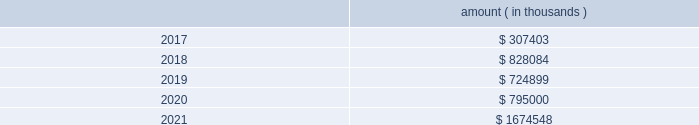Entergy corporation and subsidiaries notes to financial statements ( a ) consists of pollution control revenue bonds and environmental revenue bonds , some of which are secured by collateral first mortgage bonds .
( b ) these notes do not have a stated interest rate , but have an implicit interest rate of 4.8% ( 4.8 % ) .
( c ) pursuant to the nuclear waste policy act of 1982 , entergy 2019s nuclear owner/licensee subsidiaries have contracts with the doe for spent nuclear fuel disposal service .
The contracts include a one-time fee for generation prior to april 7 , 1983 .
Entergy arkansas is the only entergy company that generated electric power with nuclear fuel prior to that date and includes the one-time fee , plus accrued interest , in long-term debt .
( d ) see note 10 to the financial statements for further discussion of the waterford 3 lease obligation and entergy louisiana 2019s acquisition of the equity participant 2019s beneficial interest in the waterford 3 leased assets and for further discussion of the grand gulf lease obligation .
( e ) this note does not have a stated interest rate , but has an implicit interest rate of 7.458% ( 7.458 % ) .
( f ) the fair value excludes lease obligations of $ 57 million at entergy louisiana and $ 34 million at system energy , and long-term doe obligations of $ 182 million at entergy arkansas , and includes debt due within one year .
Fair values are classified as level 2 in the fair value hierarchy discussed in note 15 to the financial statements and are based on prices derived from inputs such as benchmark yields and reported trades .
The annual long-term debt maturities ( excluding lease obligations and long-term doe obligations ) for debt outstanding as of december 31 , 2016 , for the next five years are as follows : amount ( in thousands ) .
In november 2000 , entergy 2019s non-utility nuclear business purchased the fitzpatrick and indian point 3 power plants in a seller-financed transaction .
As part of the purchase agreement with nypa , entergy recorded a liability representing the net present value of the payments entergy would be liable to nypa for each year that the fitzpatrick and indian point 3 power plants would run beyond their respective original nrc license expiration date .
In october 2015 , entergy announced a planned shutdown of fitzpatrick at the end of its fuel cycle .
As a result of the announcement , entergy reduced this liability by $ 26.4 million pursuant to the terms of the purchase agreement .
In august 2016 , entergy entered into a trust transfer agreement with nypa to transfer the decommissioning trust funds and decommissioning liabilities for the indian point 3 and fitzpatrick plants to entergy .
As part of the trust transfer agreement , the original decommissioning agreements were amended , and the entergy subsidiaries 2019 obligation to make additional license extension payments to nypa was eliminated .
In the third quarter 2016 , entergy removed the note payable of $ 35.1 million from the consolidated balance sheet .
Entergy louisiana , entergy mississippi , entergy texas , and system energy have obtained long-term financing authorizations from the ferc that extend through october 2017 .
Entergy arkansas has obtained long-term financing authorization from the apsc that extends through december 2018 .
Entergy new orleans has obtained long-term financing authorization from the city council that extends through june 2018 .
Capital funds agreement pursuant to an agreement with certain creditors , entergy corporation has agreed to supply system energy with sufficient capital to : 2022 maintain system energy 2019s equity capital at a minimum of 35% ( 35 % ) of its total capitalization ( excluding short- term debt ) ; .
What amount of long-term debt is due in the next 36 months for entergy corporation as of december 31 , 2016 , in millions? 
Computations: (((307403 + 828084) + 724899) / 1000)
Answer: 1860.386. 